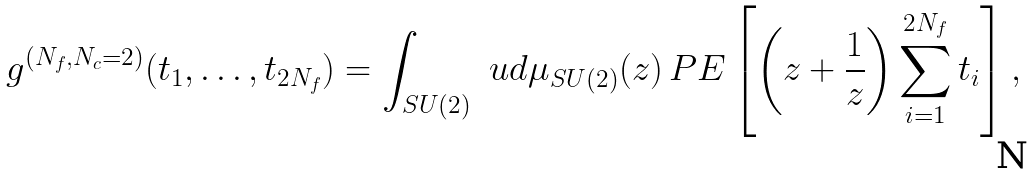<formula> <loc_0><loc_0><loc_500><loc_500>g ^ { ( N _ { f } , N _ { c } = 2 ) } ( t _ { 1 } , \dots , t _ { 2 N _ { f } } ) = \int _ { S U ( 2 ) } \ u d \mu _ { S U ( 2 ) } ( z ) \, P E \left [ \left ( z + \frac { 1 } { z } \right ) \sum _ { i = 1 } ^ { 2 N _ { f } } t _ { i } \right ] ,</formula> 